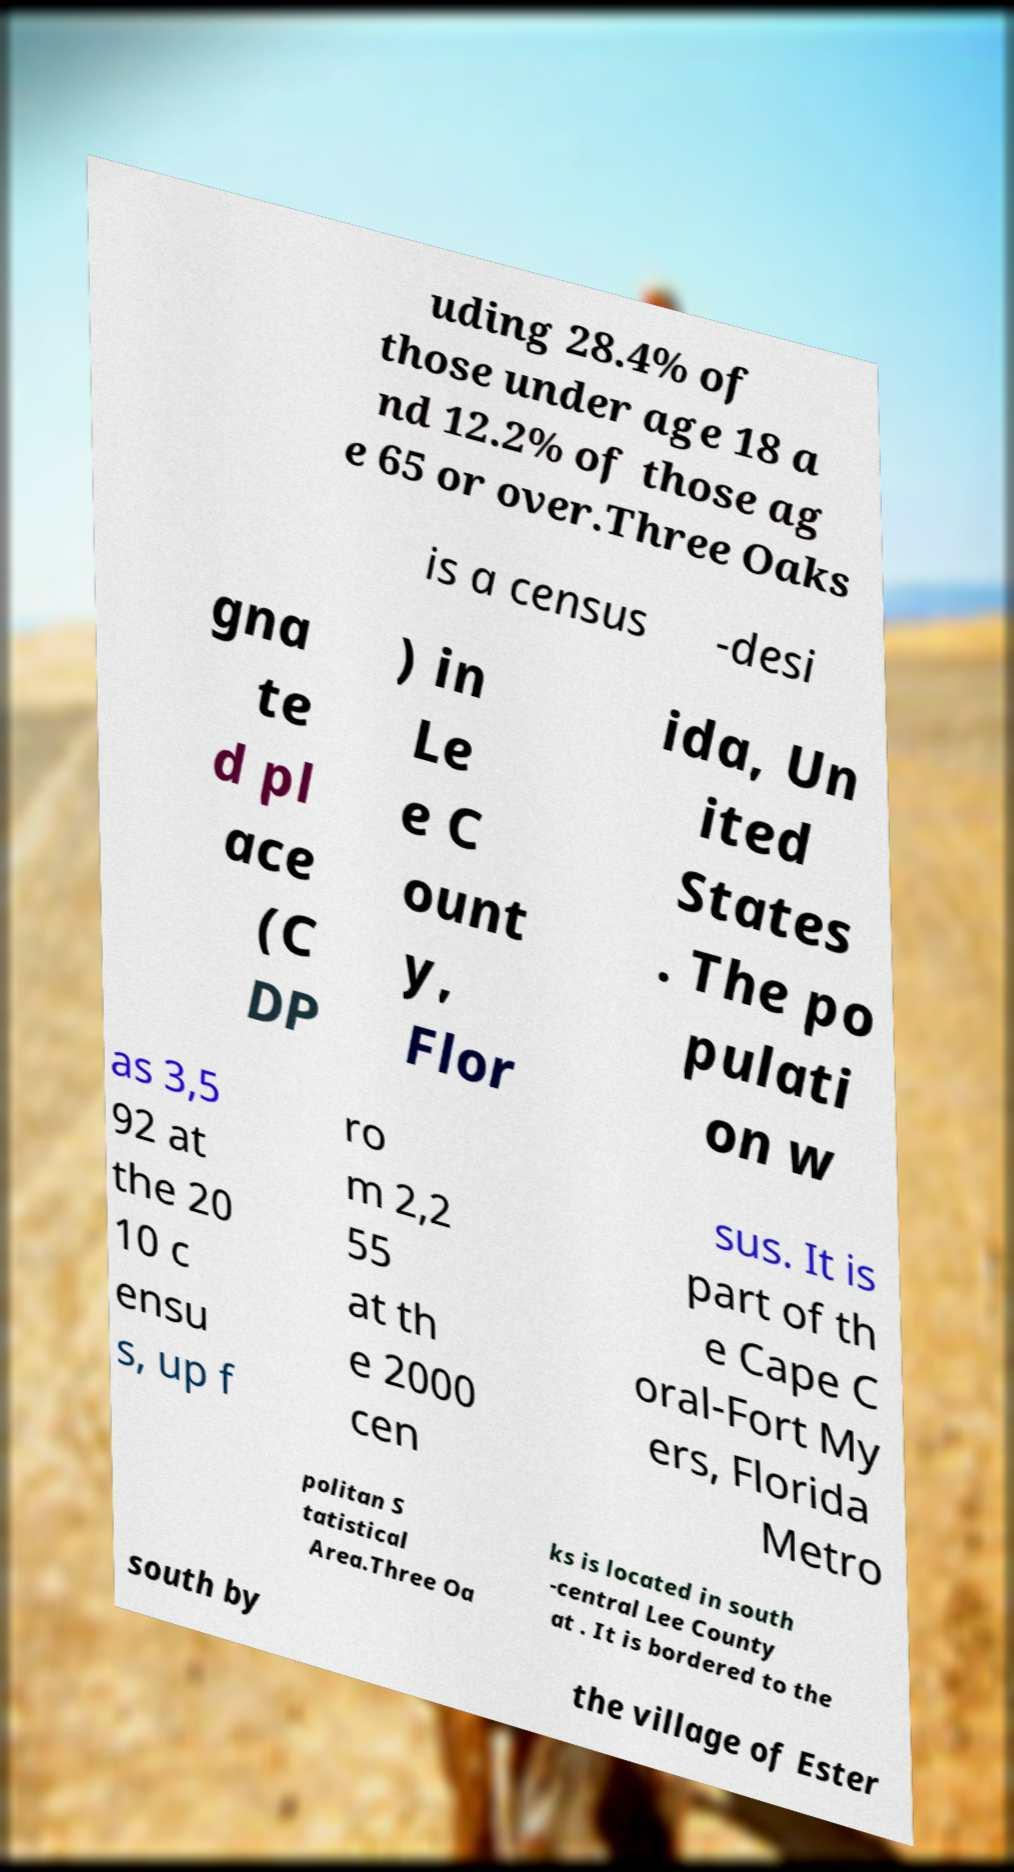Please identify and transcribe the text found in this image. uding 28.4% of those under age 18 a nd 12.2% of those ag e 65 or over.Three Oaks is a census -desi gna te d pl ace (C DP ) in Le e C ount y, Flor ida, Un ited States . The po pulati on w as 3,5 92 at the 20 10 c ensu s, up f ro m 2,2 55 at th e 2000 cen sus. It is part of th e Cape C oral-Fort My ers, Florida Metro politan S tatistical Area.Three Oa ks is located in south -central Lee County at . It is bordered to the south by the village of Ester 